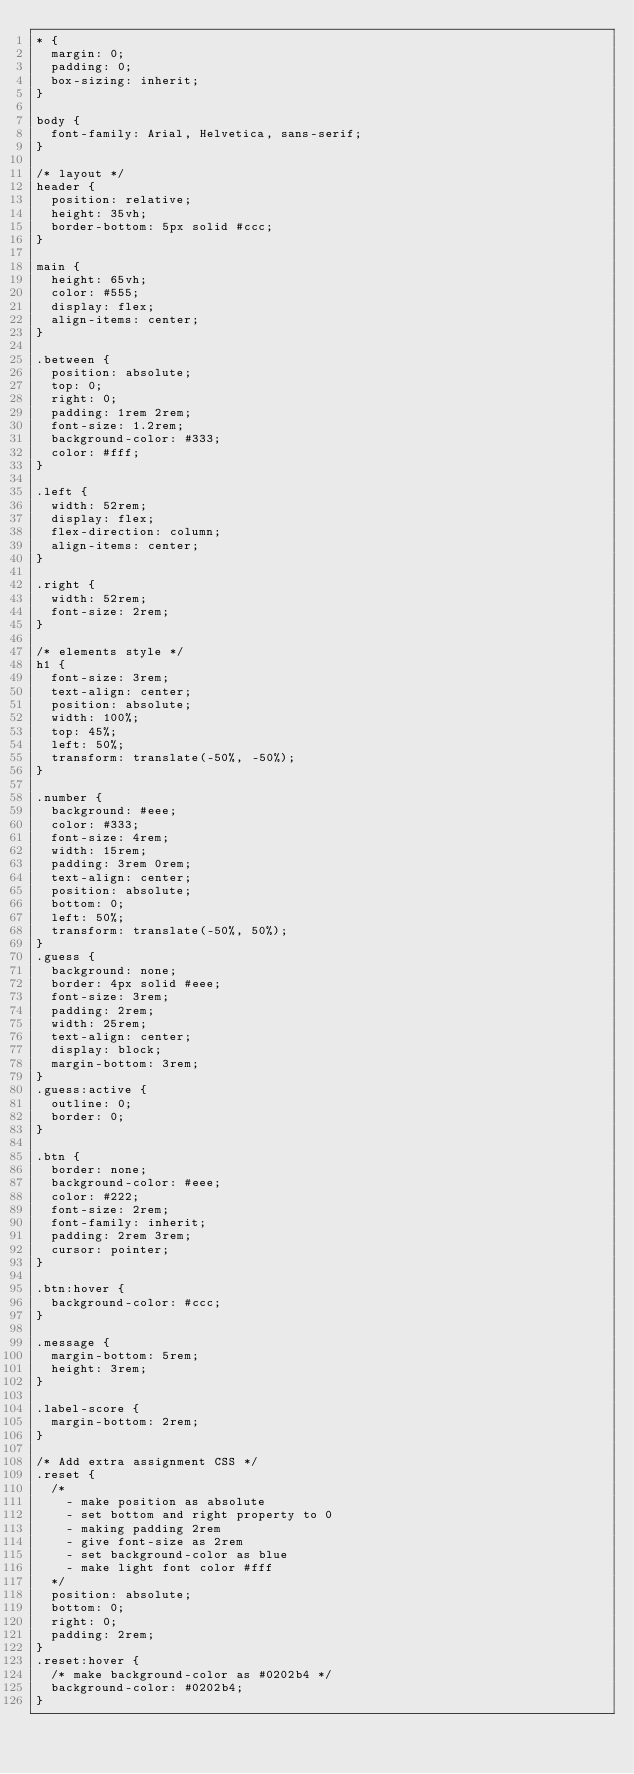<code> <loc_0><loc_0><loc_500><loc_500><_CSS_>* {
  margin: 0;
  padding: 0;
  box-sizing: inherit;
}

body {
  font-family: Arial, Helvetica, sans-serif;
}

/* layout */
header {
  position: relative;
  height: 35vh;
  border-bottom: 5px solid #ccc;
}

main {
  height: 65vh;
  color: #555;
  display: flex;
  align-items: center;
}

.between {
  position: absolute;
  top: 0;
  right: 0;
  padding: 1rem 2rem;
  font-size: 1.2rem;
  background-color: #333;
  color: #fff;
}

.left {
  width: 52rem;
  display: flex;
  flex-direction: column;
  align-items: center;
}

.right {
  width: 52rem;
  font-size: 2rem;
}

/* elements style */
h1 {
  font-size: 3rem;
  text-align: center;
  position: absolute;
  width: 100%;
  top: 45%;
  left: 50%;
  transform: translate(-50%, -50%);
}

.number {
  background: #eee;
  color: #333;
  font-size: 4rem;
  width: 15rem;
  padding: 3rem 0rem;
  text-align: center;
  position: absolute;
  bottom: 0;
  left: 50%;
  transform: translate(-50%, 50%);
}
.guess {
  background: none;
  border: 4px solid #eee;
  font-size: 3rem;
  padding: 2rem;
  width: 25rem;
  text-align: center;
  display: block;
  margin-bottom: 3rem;
}
.guess:active {
  outline: 0;
  border: 0;
}

.btn {
  border: none;
  background-color: #eee;
  color: #222;
  font-size: 2rem;
  font-family: inherit;
  padding: 2rem 3rem;
  cursor: pointer;
}

.btn:hover {
  background-color: #ccc;
}

.message {
  margin-bottom: 5rem;
  height: 3rem;
}

.label-score {
  margin-bottom: 2rem;
}

/* Add extra assignment CSS */
.reset {
  /*
    - make position as absolute
    - set bottom and right property to 0
    - making padding 2rem
    - give font-size as 2rem
    - set background-color as blue
    - make light font color #fff
  */
  position: absolute;
  bottom: 0;
  right: 0;
  padding: 2rem;
}
.reset:hover {
  /* make background-color as #0202b4 */
  background-color: #0202b4;
}
</code> 